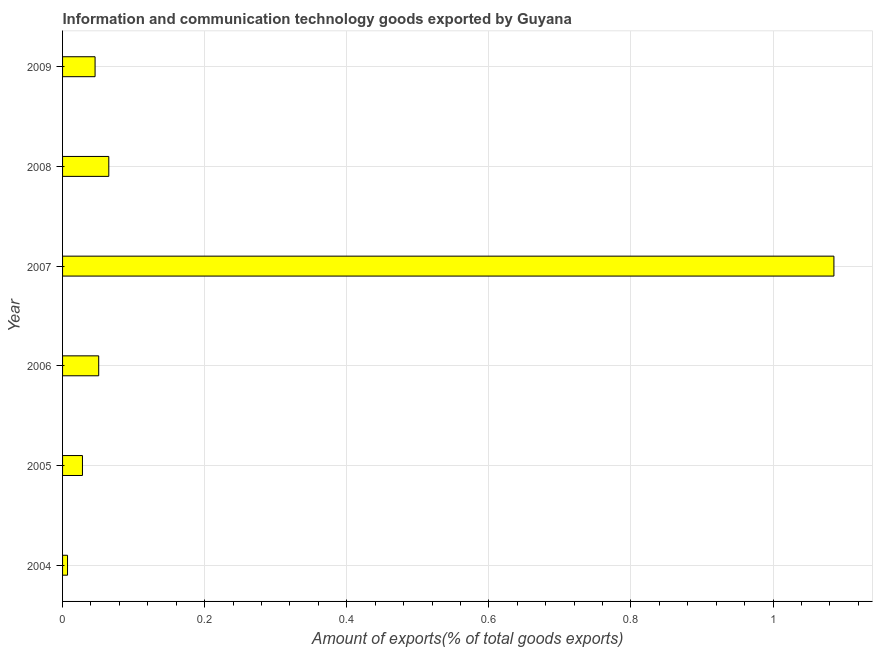Does the graph contain any zero values?
Ensure brevity in your answer.  No. Does the graph contain grids?
Your response must be concise. Yes. What is the title of the graph?
Your answer should be compact. Information and communication technology goods exported by Guyana. What is the label or title of the X-axis?
Ensure brevity in your answer.  Amount of exports(% of total goods exports). What is the label or title of the Y-axis?
Ensure brevity in your answer.  Year. What is the amount of ict goods exports in 2004?
Your answer should be compact. 0.01. Across all years, what is the maximum amount of ict goods exports?
Offer a very short reply. 1.09. Across all years, what is the minimum amount of ict goods exports?
Your response must be concise. 0.01. In which year was the amount of ict goods exports minimum?
Provide a succinct answer. 2004. What is the sum of the amount of ict goods exports?
Provide a succinct answer. 1.28. What is the difference between the amount of ict goods exports in 2005 and 2006?
Provide a succinct answer. -0.02. What is the average amount of ict goods exports per year?
Your answer should be very brief. 0.21. What is the median amount of ict goods exports?
Your answer should be compact. 0.05. Do a majority of the years between 2006 and 2007 (inclusive) have amount of ict goods exports greater than 0.92 %?
Your response must be concise. No. What is the ratio of the amount of ict goods exports in 2004 to that in 2008?
Offer a terse response. 0.11. What is the difference between the highest and the second highest amount of ict goods exports?
Give a very brief answer. 1.02. What is the difference between the highest and the lowest amount of ict goods exports?
Offer a very short reply. 1.08. What is the Amount of exports(% of total goods exports) in 2004?
Make the answer very short. 0.01. What is the Amount of exports(% of total goods exports) of 2005?
Offer a very short reply. 0.03. What is the Amount of exports(% of total goods exports) of 2006?
Offer a terse response. 0.05. What is the Amount of exports(% of total goods exports) in 2007?
Give a very brief answer. 1.09. What is the Amount of exports(% of total goods exports) in 2008?
Your answer should be very brief. 0.07. What is the Amount of exports(% of total goods exports) in 2009?
Provide a succinct answer. 0.05. What is the difference between the Amount of exports(% of total goods exports) in 2004 and 2005?
Provide a succinct answer. -0.02. What is the difference between the Amount of exports(% of total goods exports) in 2004 and 2006?
Offer a terse response. -0.04. What is the difference between the Amount of exports(% of total goods exports) in 2004 and 2007?
Provide a short and direct response. -1.08. What is the difference between the Amount of exports(% of total goods exports) in 2004 and 2008?
Your response must be concise. -0.06. What is the difference between the Amount of exports(% of total goods exports) in 2004 and 2009?
Your answer should be compact. -0.04. What is the difference between the Amount of exports(% of total goods exports) in 2005 and 2006?
Your response must be concise. -0.02. What is the difference between the Amount of exports(% of total goods exports) in 2005 and 2007?
Your answer should be very brief. -1.06. What is the difference between the Amount of exports(% of total goods exports) in 2005 and 2008?
Keep it short and to the point. -0.04. What is the difference between the Amount of exports(% of total goods exports) in 2005 and 2009?
Make the answer very short. -0.02. What is the difference between the Amount of exports(% of total goods exports) in 2006 and 2007?
Your response must be concise. -1.03. What is the difference between the Amount of exports(% of total goods exports) in 2006 and 2008?
Provide a short and direct response. -0.01. What is the difference between the Amount of exports(% of total goods exports) in 2006 and 2009?
Your answer should be very brief. 0.01. What is the difference between the Amount of exports(% of total goods exports) in 2007 and 2008?
Make the answer very short. 1.02. What is the difference between the Amount of exports(% of total goods exports) in 2007 and 2009?
Keep it short and to the point. 1.04. What is the difference between the Amount of exports(% of total goods exports) in 2008 and 2009?
Your answer should be very brief. 0.02. What is the ratio of the Amount of exports(% of total goods exports) in 2004 to that in 2005?
Provide a short and direct response. 0.25. What is the ratio of the Amount of exports(% of total goods exports) in 2004 to that in 2006?
Your response must be concise. 0.14. What is the ratio of the Amount of exports(% of total goods exports) in 2004 to that in 2007?
Make the answer very short. 0.01. What is the ratio of the Amount of exports(% of total goods exports) in 2004 to that in 2008?
Offer a terse response. 0.11. What is the ratio of the Amount of exports(% of total goods exports) in 2004 to that in 2009?
Your answer should be compact. 0.15. What is the ratio of the Amount of exports(% of total goods exports) in 2005 to that in 2006?
Provide a short and direct response. 0.55. What is the ratio of the Amount of exports(% of total goods exports) in 2005 to that in 2007?
Offer a very short reply. 0.03. What is the ratio of the Amount of exports(% of total goods exports) in 2005 to that in 2008?
Provide a succinct answer. 0.43. What is the ratio of the Amount of exports(% of total goods exports) in 2005 to that in 2009?
Provide a short and direct response. 0.61. What is the ratio of the Amount of exports(% of total goods exports) in 2006 to that in 2007?
Ensure brevity in your answer.  0.05. What is the ratio of the Amount of exports(% of total goods exports) in 2006 to that in 2008?
Your response must be concise. 0.78. What is the ratio of the Amount of exports(% of total goods exports) in 2006 to that in 2009?
Your response must be concise. 1.11. What is the ratio of the Amount of exports(% of total goods exports) in 2007 to that in 2008?
Give a very brief answer. 16.69. What is the ratio of the Amount of exports(% of total goods exports) in 2007 to that in 2009?
Provide a short and direct response. 23.73. What is the ratio of the Amount of exports(% of total goods exports) in 2008 to that in 2009?
Provide a short and direct response. 1.42. 